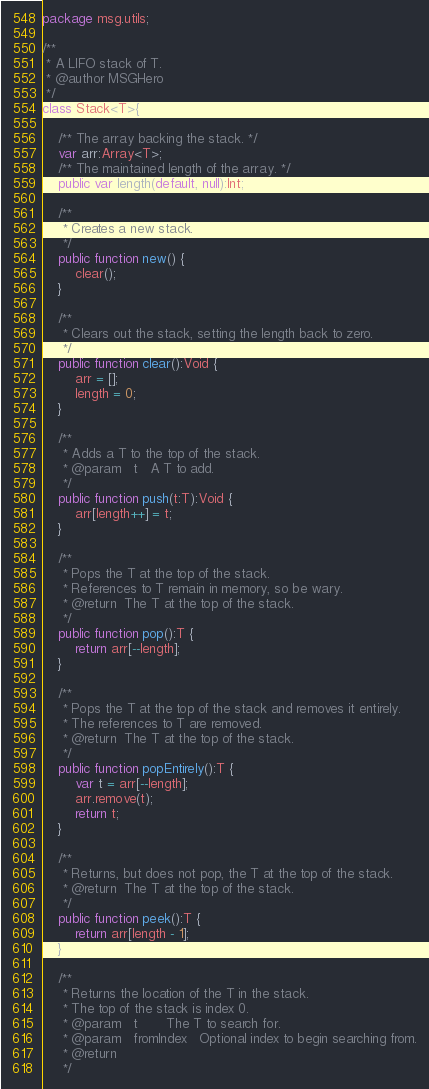Convert code to text. <code><loc_0><loc_0><loc_500><loc_500><_Haxe_>package msg.utils;

/**
 * A LIFO stack of T.
 * @author MSGHero
 */
class Stack<T>{

	/** The array backing the stack. */
	var arr:Array<T>;
	/** The maintained length of the array. */
	public var length(default, null):Int;
	
	/**
	 * Creates a new stack.
	 */
	public function new() {
		clear();
	}
	
	/**
	 * Clears out the stack, setting the length back to zero.
	 */
	public function clear():Void {
		arr = [];
		length = 0;
	}
	
	/**
	 * Adds a T to the top of the stack.
	 * @param	t	A T to add.
	 */
	public function push(t:T):Void {
		arr[length++] = t;
	}
	
	/**
	 * Pops the T at the top of the stack.
	 * References to T remain in memory, so be wary.
	 * @return	The T at the top of the stack.
	 */
	public function pop():T {
		return arr[--length];
	}
	
	/**
	 * Pops the T at the top of the stack and removes it entirely.
	 * The references to T are removed.
	 * @return	The T at the top of the stack.
	 */
	public function popEntirely():T {
		var t = arr[--length];
		arr.remove(t);
		return t;
	}
	
	/**
	 * Returns, but does not pop, the T at the top of the stack.
	 * @return	The T at the top of the stack.
	 */
	public function peek():T {
		return arr[length - 1];
	}
	
	/**
	 * Returns the location of the T in the stack.
	 * The top of the stack is index 0.
	 * @param	t		The T to search for.
	 * @param	fromIndex	Optional index to begin searching from.
	 * @return
	 */</code> 